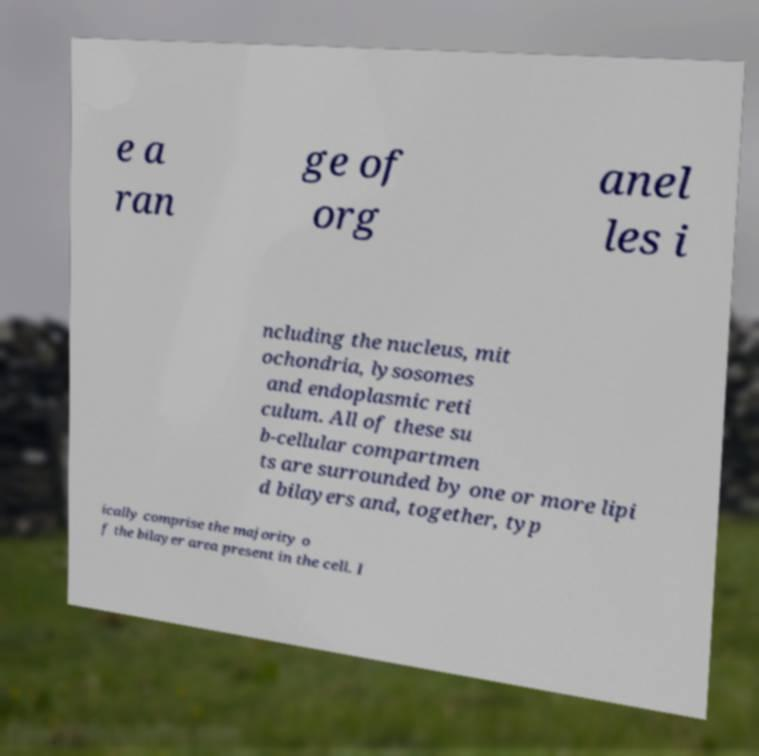Please identify and transcribe the text found in this image. e a ran ge of org anel les i ncluding the nucleus, mit ochondria, lysosomes and endoplasmic reti culum. All of these su b-cellular compartmen ts are surrounded by one or more lipi d bilayers and, together, typ ically comprise the majority o f the bilayer area present in the cell. I 